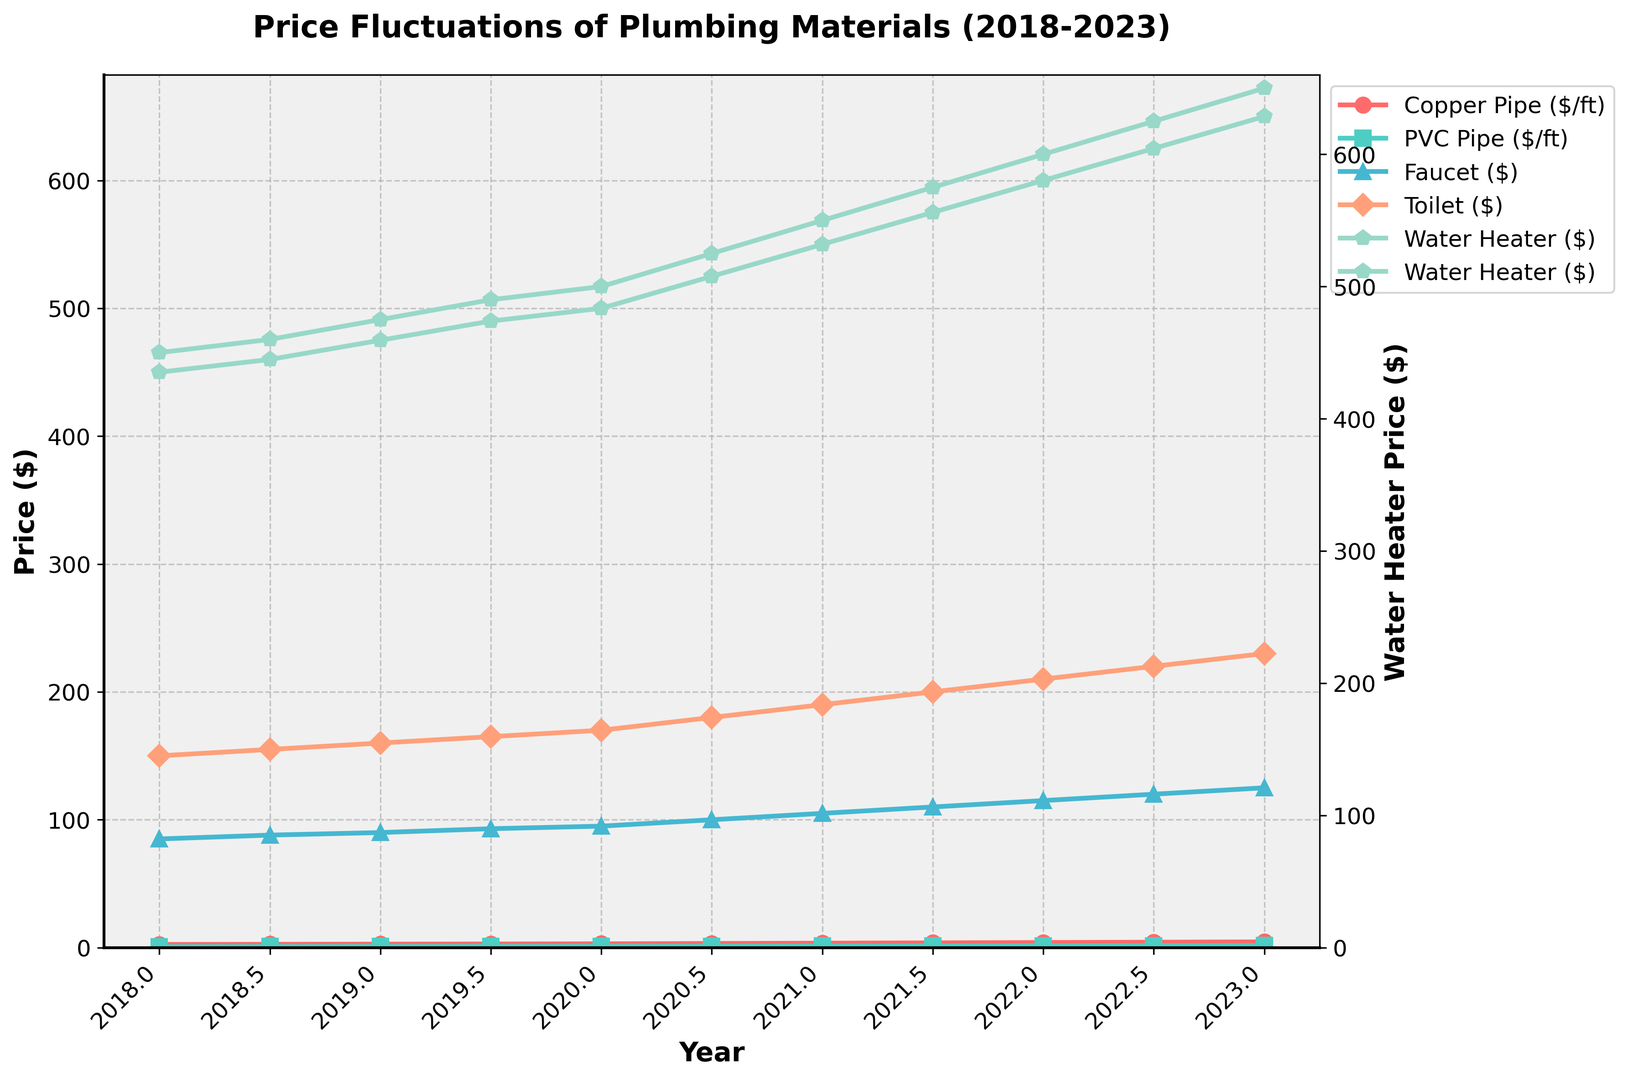What was the price of a copper pipe per foot in 2018? Look at the section of the line chart representing copper pipes (marked with circles and red color). The 2018 value corresponds to $2.50.
Answer: $2.50 Which year experienced the highest price for PVC pipes? Observe the green-colored line with square markers representing PVC pipes. The highest point on this line occurs at 2023, with a price of $1.60 per foot.
Answer: 2023 What is the price difference between a faucet and a toilet in 2019.5? Locate the prices on the lines representing the faucet (blue with triangle markers) and the toilet (orange with diamond markers) for 2019.5. The faucet costs $93 and the toilet costs $165. Subtract these values: $165 - $93 = $72.
Answer: $72 Which material showed the most significant price increase from 2019 to 2021? Examine the prices for each material in 2019 and 2021. For copper pipes: $2.75 to $3.50, a $0.75 increase; for PVC pipes: $0.90 to $1.20, a $0.30 increase; for faucets: $90 to $105, a $15 increase; for toilets: $160 to $190, a $30 increase; for water heaters: $475 to $550, a $75 increase. The water heater had the largest increase.
Answer: Water Heater On average, what was the price of a PVC pipe per foot annually between 2020 and 2023? Determine the prices for PVC pipes from 2020 to 2023: $1.00, $1.10, $1.20, $1.30, $1.40, $1.50, $1.60. Calculate the average: (1.00 + 1.10 + 1.20 + 1.30 + 1.40 + 1.50 + 1.60) / 7.
Answer: $1.30 How does the price trend of copper pipes compare to that of faucets between 2018 and 2023? Observe the price lines for copper pipes (red with circle markers) and faucets (blue with triangle markers). Both exhibit an upward trend, but copper pipes increase more sharply.
Answer: Both increased, but copper increased more sharply Which item had the steepest price increase in 2020.5? Check all lines at the year mark 2020.5. The copper pipe price went from $3.00 to $3.25, the PVC pipe from $1.00 to $1.10, the faucet from $95 to $100, the toilet from $170 to $180, the water heater from $500 to $525. The water heater rose the most, by $25.
Answer: Water Heater What color represents the water heater prices, and what is its trend from 2018 to 2023? The water heater line (purple-pentagon markers) steadily rises from 2018 to 2023, indicating a consistent increase in prices.
Answer: Purple, rising trend 